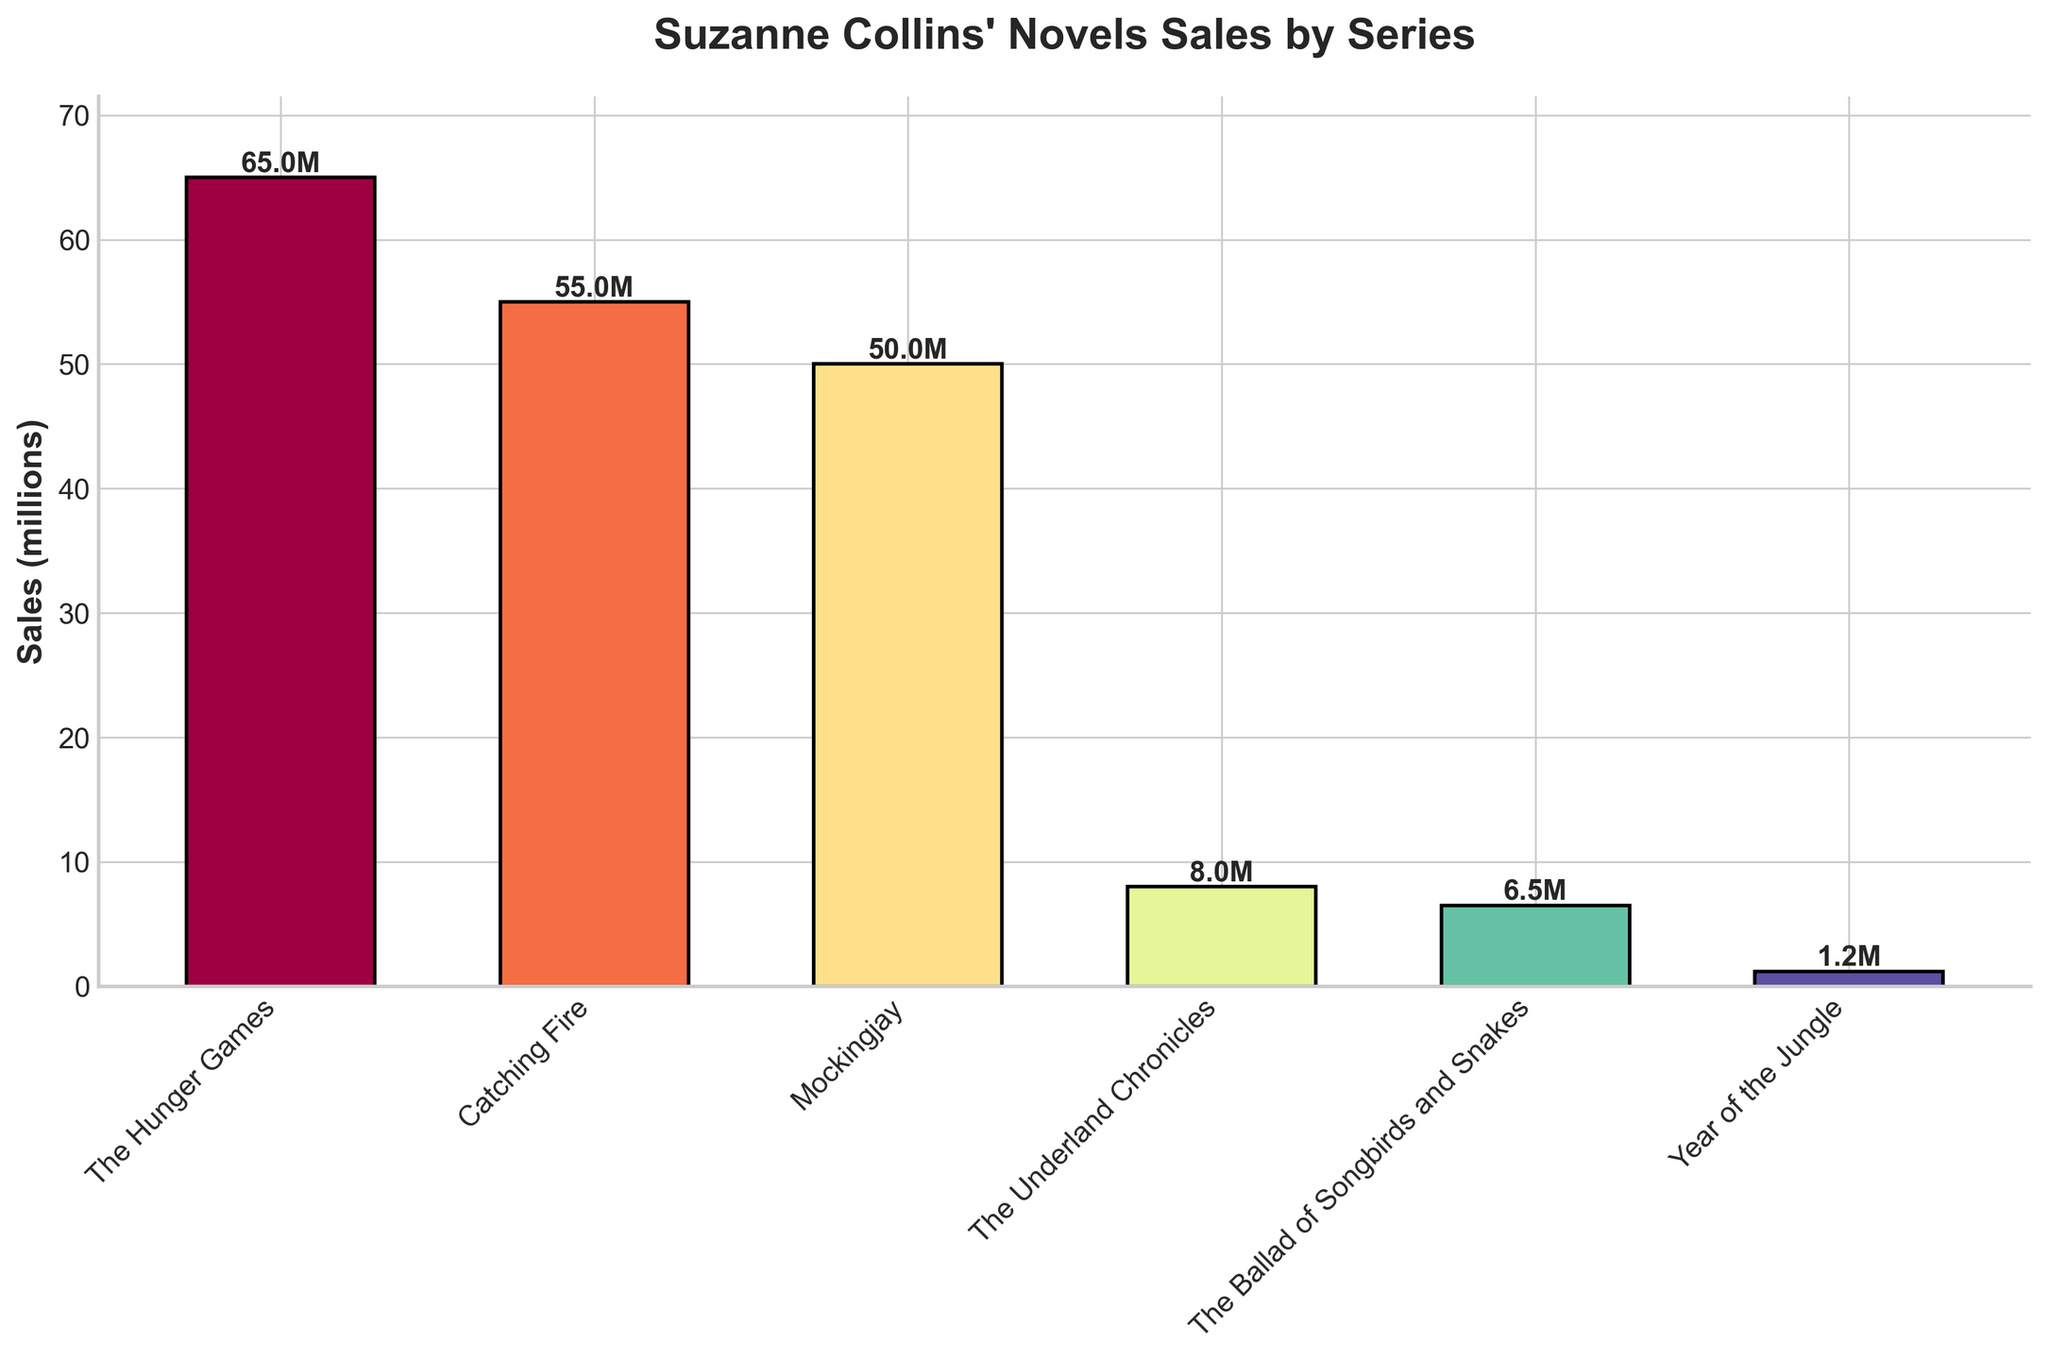Which series has the highest sales? The series with the tallest bar represents the highest sales. The tallest bar is for "The Hunger Games", indicating it has the highest sales.
Answer: The Hunger Games What is the total sales for "Catching Fire" and "Mockingjay"? Add the sales figures for both "Catching Fire" and "Mockingjay". Catching Fire has 55 million, and Mockingjay has 50 million sales. 55 + 50 = 105 million.
Answer: 105 million Which series has the least sales? The series with the shortest bar represents the least sales. The shortest bar is for "Year of the Jungle", indicating it has the least sales.
Answer: Year of the Jungle How much more did "The Hunger Games" sell compared to the "Underland Chronicles"? Subtract the sales of "Underland Chronicles" from the sales of "The Hunger Games". The Hunger Games sold 65 million, and The Underland Chronicles sold 8 million. 65 - 8 = 57 million.
Answer: 57 million What is the average sales of the series "The Ballad of Songbirds and Snakes" and "Year of the Jungle"? Add the sales for both "The Ballad of Songbirds and Snakes" and "Year of the Jungle", then divide by 2. The Ballad of Songbirds and Snakes sold 6.5 million, and Year of the Jungle sold 1.2 million. (6.5 + 1.2) / 2 = 3.85 million.
Answer: 3.85 million Is the sales of "Catching Fire" greater than "Mockingjay"? Compare the two sales figures. "Catching Fire" has 55 million, and "Mockingjay" has 50 million sales. 55 is greater than 50.
Answer: Yes What is the difference in sales between "The Hunger Games" and "The Ballad of Songbirds and Snakes"? Subtract the smaller sales figure from the larger one. The Hunger Games sold 65 million, and The Ballad of Songbirds and Snakes sold 6.5 million. 65 - 6.5 = 58.5 million.
Answer: 58.5 million What proportion of the total sales does "The Hunger Games" account for? First, calculate the total sales for all series, then find what proportion "The Hunger Games" sales are of this total. Total sales = 65 + 55 + 50 + 8 + 6.5 + 1.2 = 185.7 million. Proportion = 65 / 185.7 ≈ 0.35 or 35%.
Answer: 35% Which series has a sales figure between "The Ballad of Songbirds and Snakes" and "The Underland Chronicles"? Identify the series whose sales value is between 6.5 million and 8 million. None of the series listed falls in this range based on the data provided.
Answer: None Rank the series in descending order of their sales. Order the series based on their sales from highest to lowest. The order is "The Hunger Games" (65 million), "Catching Fire" (55 million), "Mockingjay" (50 million), "The Underland Chronicles" (8 million), "The Ballad of Songbirds and Snakes" (6.5 million), and "Year of the Jungle" (1.2 million).
Answer: The Hunger Games > Catching Fire > Mockingjay > The Underland Chronicles > The Ballad of Songbirds and Snakes > Year of the Jungle 